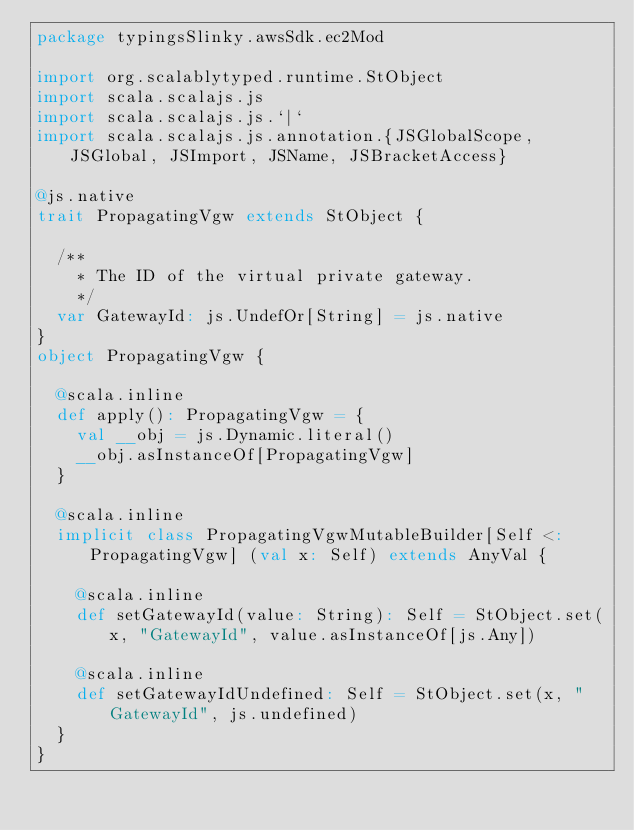Convert code to text. <code><loc_0><loc_0><loc_500><loc_500><_Scala_>package typingsSlinky.awsSdk.ec2Mod

import org.scalablytyped.runtime.StObject
import scala.scalajs.js
import scala.scalajs.js.`|`
import scala.scalajs.js.annotation.{JSGlobalScope, JSGlobal, JSImport, JSName, JSBracketAccess}

@js.native
trait PropagatingVgw extends StObject {
  
  /**
    * The ID of the virtual private gateway.
    */
  var GatewayId: js.UndefOr[String] = js.native
}
object PropagatingVgw {
  
  @scala.inline
  def apply(): PropagatingVgw = {
    val __obj = js.Dynamic.literal()
    __obj.asInstanceOf[PropagatingVgw]
  }
  
  @scala.inline
  implicit class PropagatingVgwMutableBuilder[Self <: PropagatingVgw] (val x: Self) extends AnyVal {
    
    @scala.inline
    def setGatewayId(value: String): Self = StObject.set(x, "GatewayId", value.asInstanceOf[js.Any])
    
    @scala.inline
    def setGatewayIdUndefined: Self = StObject.set(x, "GatewayId", js.undefined)
  }
}
</code> 